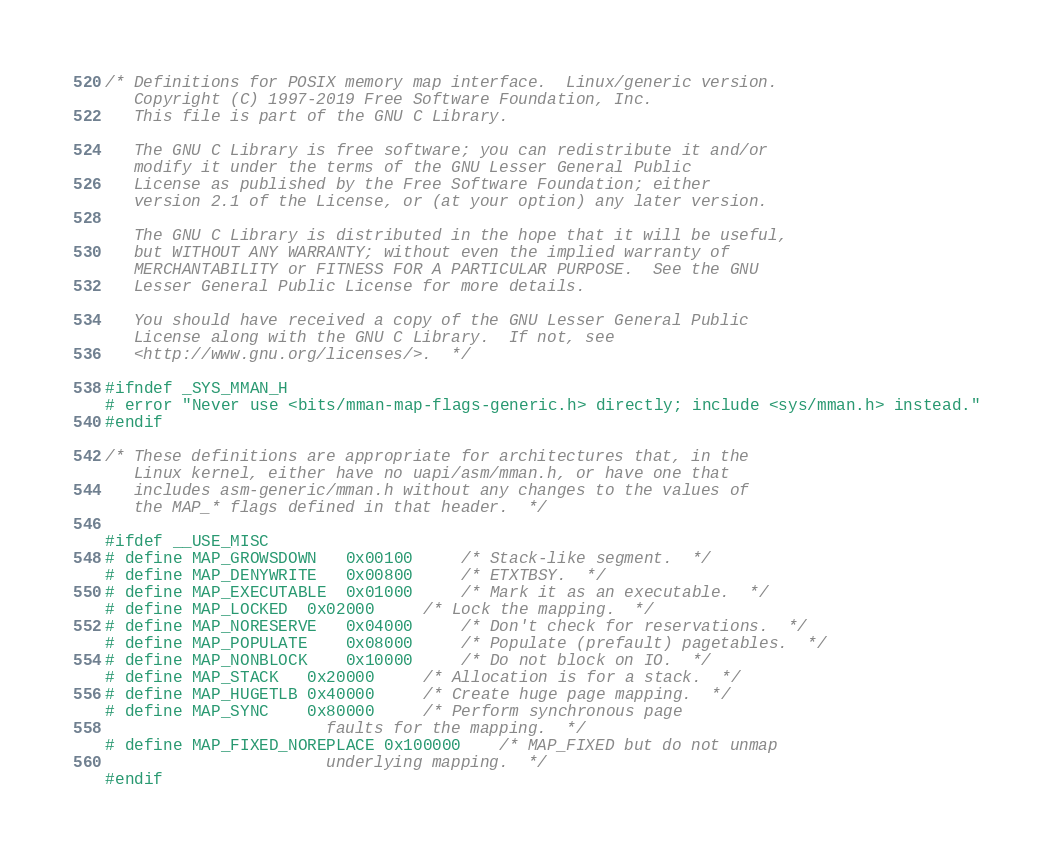Convert code to text. <code><loc_0><loc_0><loc_500><loc_500><_C_>/* Definitions for POSIX memory map interface.  Linux/generic version.
   Copyright (C) 1997-2019 Free Software Foundation, Inc.
   This file is part of the GNU C Library.

   The GNU C Library is free software; you can redistribute it and/or
   modify it under the terms of the GNU Lesser General Public
   License as published by the Free Software Foundation; either
   version 2.1 of the License, or (at your option) any later version.

   The GNU C Library is distributed in the hope that it will be useful,
   but WITHOUT ANY WARRANTY; without even the implied warranty of
   MERCHANTABILITY or FITNESS FOR A PARTICULAR PURPOSE.  See the GNU
   Lesser General Public License for more details.

   You should have received a copy of the GNU Lesser General Public
   License along with the GNU C Library.  If not, see
   <http://www.gnu.org/licenses/>.  */

#ifndef _SYS_MMAN_H
# error "Never use <bits/mman-map-flags-generic.h> directly; include <sys/mman.h> instead."
#endif

/* These definitions are appropriate for architectures that, in the
   Linux kernel, either have no uapi/asm/mman.h, or have one that
   includes asm-generic/mman.h without any changes to the values of
   the MAP_* flags defined in that header.  */

#ifdef __USE_MISC
# define MAP_GROWSDOWN	0x00100		/* Stack-like segment.  */
# define MAP_DENYWRITE	0x00800		/* ETXTBSY.  */
# define MAP_EXECUTABLE	0x01000		/* Mark it as an executable.  */
# define MAP_LOCKED	0x02000		/* Lock the mapping.  */
# define MAP_NORESERVE	0x04000		/* Don't check for reservations.  */
# define MAP_POPULATE	0x08000		/* Populate (prefault) pagetables.  */
# define MAP_NONBLOCK	0x10000		/* Do not block on IO.  */
# define MAP_STACK	0x20000		/* Allocation is for a stack.  */
# define MAP_HUGETLB	0x40000		/* Create huge page mapping.  */
# define MAP_SYNC	0x80000		/* Perform synchronous page
					   faults for the mapping.  */
# define MAP_FIXED_NOREPLACE 0x100000	/* MAP_FIXED but do not unmap
					   underlying mapping.  */
#endif
</code> 